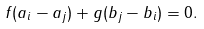Convert formula to latex. <formula><loc_0><loc_0><loc_500><loc_500>f ( a _ { i } - a _ { j } ) + g ( b _ { j } - b _ { i } ) = 0 .</formula> 